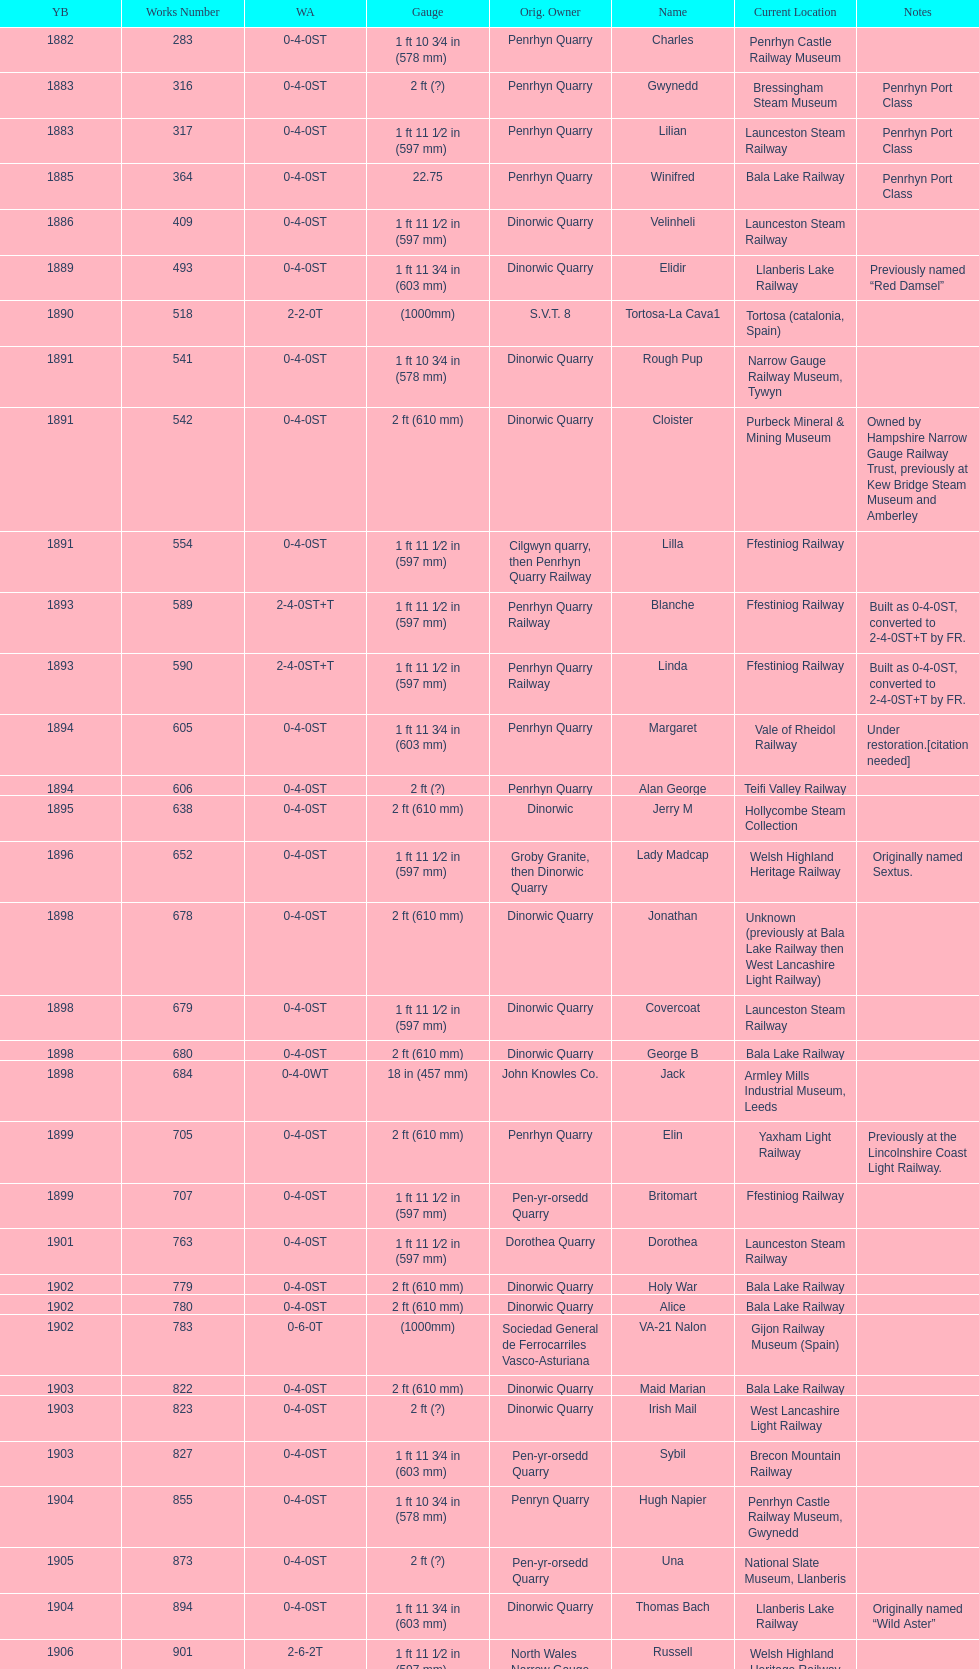What is the difference in gauge between works numbers 541 and 542? 32 mm. 